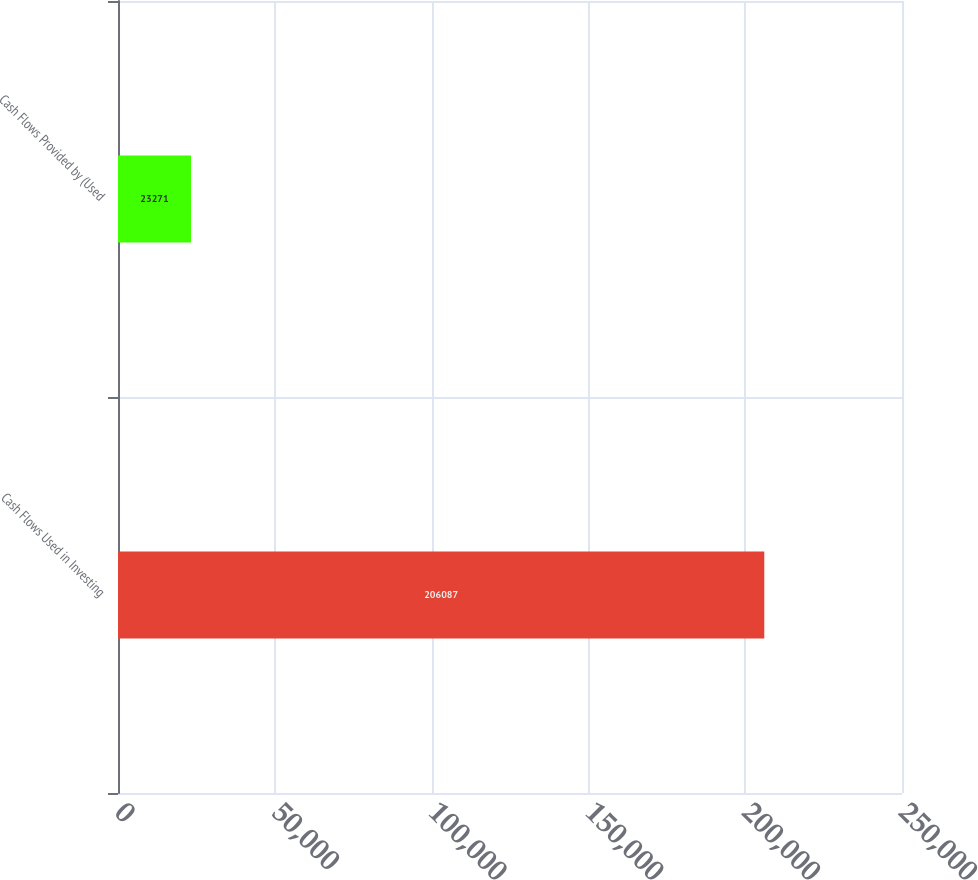Convert chart. <chart><loc_0><loc_0><loc_500><loc_500><bar_chart><fcel>Cash Flows Used in Investing<fcel>Cash Flows Provided by (Used<nl><fcel>206087<fcel>23271<nl></chart> 